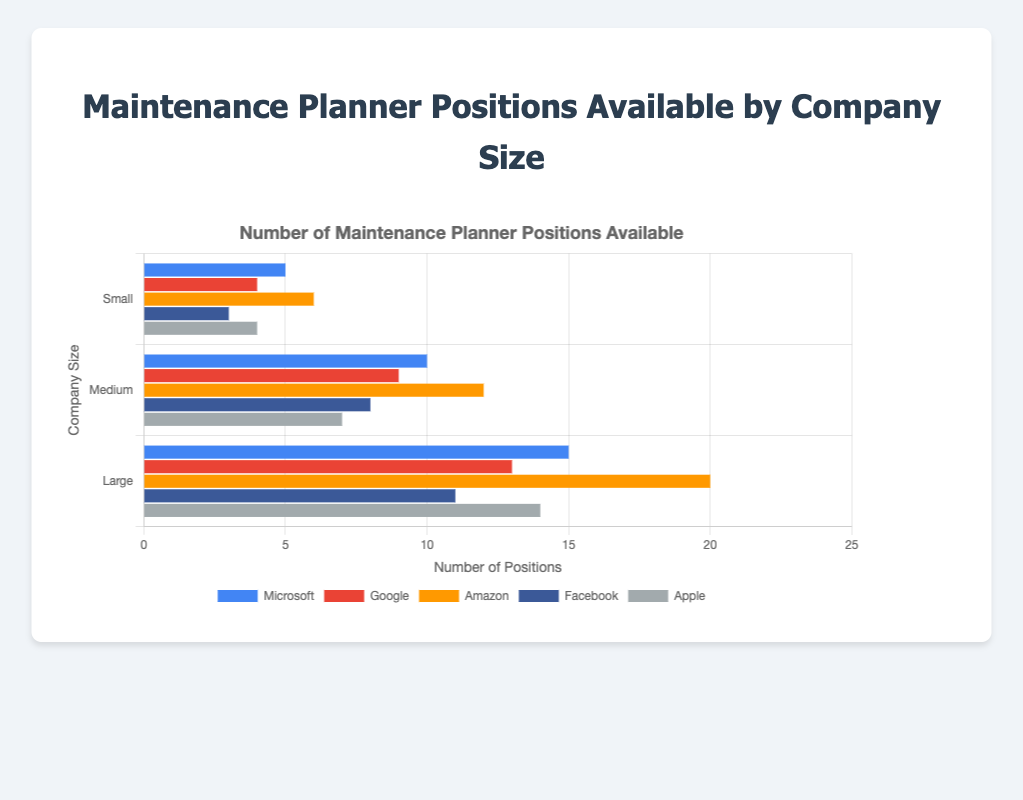What is the total number of maintenance planner positions available at Amazon across all company sizes? Add the values for Amazon across all company sizes: Small (6) + Medium (12) + Large (20) = 38
Answer: 38 Which company has the highest number of large-sized maintenance planner positions? Compare the values in the "Large" category: Microsoft (15), Google (13), Amazon (20), Facebook (11), Apple (14). Amazon has the highest number (20)
Answer: Amazon How many more maintenance planner positions does Google have in medium-sized companies compared to small-sized companies? Subtract the number of positions for Google in small companies (4) from the number in medium companies (9): 9 - 4 = 5
Answer: 5 Among the small-sized company positions, which company has the least number of maintenance planner positions? Compare the values in the "Small" category: Microsoft (5), Google (4), Amazon (6), Facebook (3), Apple (4). Facebook has the least (3)
Answer: Facebook What is the average number of maintenance planner positions for Apple across all company sizes? Sum the values for Apple (4 + 7 + 14 = 25) and divide by the number of sizes (3): 25 / 3 ≈ 8.33
Answer: 8.33 Does Microsoft have more medium-sized maintenance planner positions than Facebook has across all sizes? Compare Microsoft's medium value (10) with Facebook's total across all sizes: Facebook (3 + 8 + 11 = 22). 10 < 22, so Microsoft has fewer
Answer: No What is the difference between the total number of positions for small and large companies for all companies combined? Sum the values for all companies in the "Small" category: 5+4+6+3+4 = 22; sum the values in the "Large" category: 15+13+20+11+14 = 73; then subtract: 73 - 22 = 51
Answer: 51 Which company's bars are represented in orange? Identify the company with the orange bars in the datasets provided: Amazon's data is represented by the orange bars
Answer: Amazon How does the number of maintenance planner positions available in medium-sized companies at Facebook compare to those in large-sized companies at Google? Compare Facebook's medium value (8) with Google's large value (13). 8 < 13, so Facebook has fewer
Answer: Fewer If we combine the small-sized positions of Microsoft and Google, does it exceed the medium-sized positions of Apple? Add Microsoft's and Google's small values (5 + 4 = 9); compare this sum with Apple's medium value (7). 9 > 7, so it does exceed
Answer: Yes 